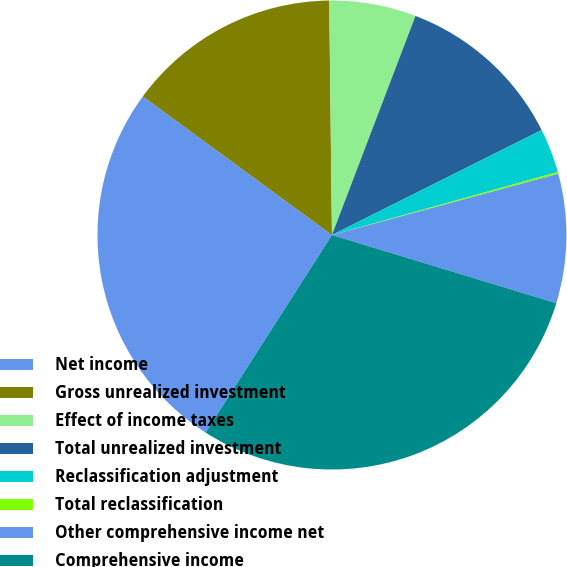Convert chart. <chart><loc_0><loc_0><loc_500><loc_500><pie_chart><fcel>Net income<fcel>Gross unrealized investment<fcel>Effect of income taxes<fcel>Total unrealized investment<fcel>Reclassification adjustment<fcel>Total reclassification<fcel>Other comprehensive income net<fcel>Comprehensive income<nl><fcel>26.01%<fcel>14.75%<fcel>5.98%<fcel>11.82%<fcel>3.05%<fcel>0.13%<fcel>8.9%<fcel>29.36%<nl></chart> 